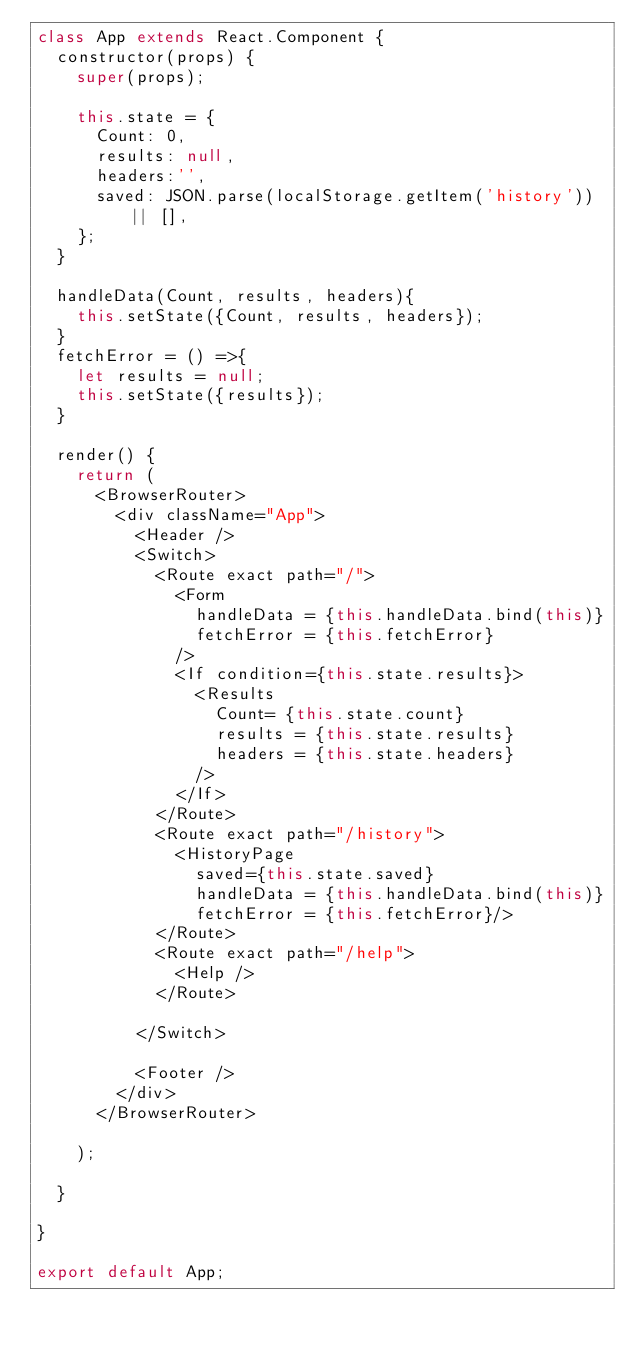Convert code to text. <code><loc_0><loc_0><loc_500><loc_500><_JavaScript_>class App extends React.Component {
  constructor(props) {
    super(props);

    this.state = {
      Count: 0,
      results: null,
      headers:'',
      saved: JSON.parse(localStorage.getItem('history')) || [],
    };
  }

  handleData(Count, results, headers){
    this.setState({Count, results, headers});
  }
  fetchError = () =>{
    let results = null;
    this.setState({results});
  }

  render() {
    return (
      <BrowserRouter>
        <div className="App">
          <Header />
          <Switch>
            <Route exact path="/">
              <Form
                handleData = {this.handleData.bind(this)}
                fetchError = {this.fetchError}
              />
              <If condition={this.state.results}>
                <Results 
                  Count= {this.state.count}
                  results = {this.state.results}
                  headers = {this.state.headers}
                />
              </If>
            </Route>
            <Route exact path="/history">
              <HistoryPage 
                saved={this.state.saved}
                handleData = {this.handleData.bind(this)}
                fetchError = {this.fetchError}/>
            </Route>
            <Route exact path="/help">
              <Help />
            </Route>

          </Switch>

          <Footer />
        </div>
      </BrowserRouter>

    );

  }

}

export default App;
</code> 